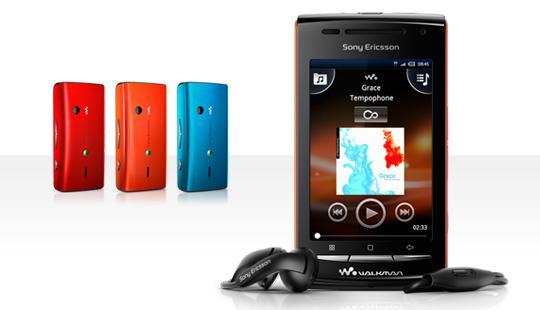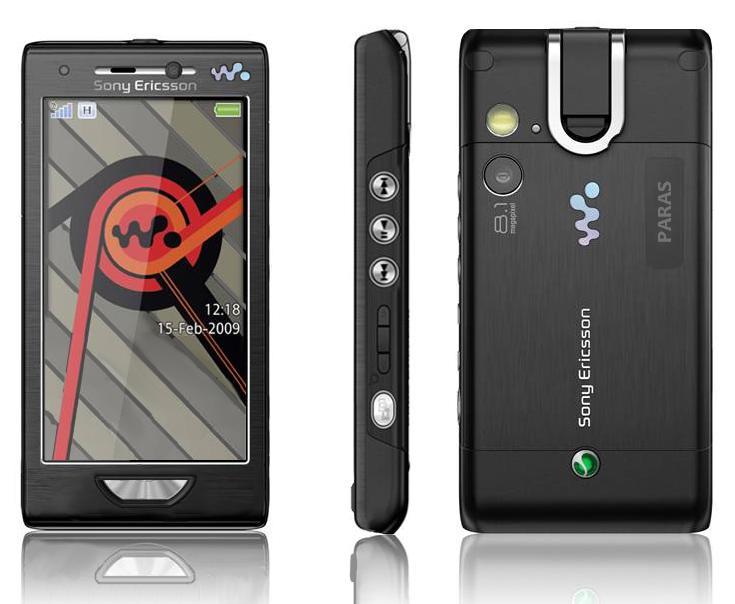The first image is the image on the left, the second image is the image on the right. For the images displayed, is the sentence "The combined images include at least one side view of a device, at least two front views of a device with an image on the screen, and at least one head-on view of the back of a device." factually correct? Answer yes or no. Yes. The first image is the image on the left, the second image is the image on the right. Analyze the images presented: Is the assertion "Each image in the pair shows multiple views of a mobile device." valid? Answer yes or no. Yes. 